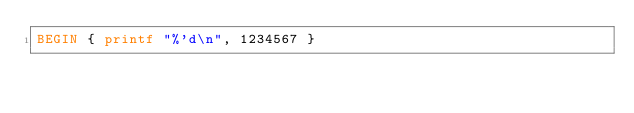Convert code to text. <code><loc_0><loc_0><loc_500><loc_500><_Awk_>BEGIN { printf "%'d\n", 1234567 }
</code> 